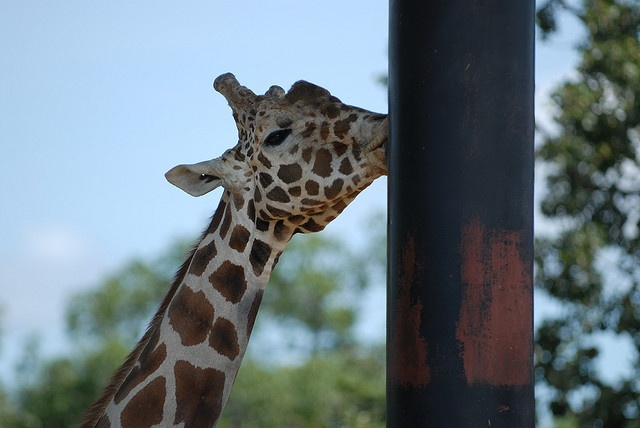Describe the objects in this image and their specific colors. I can see a giraffe in lightblue, black, and gray tones in this image. 